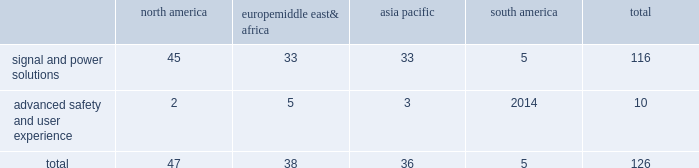Adequacy of our provision for income taxes , we regularly assess the likelihood of adverse outcomes resulting from tax examinations .
While it is often difficult to predict the final outcome or the timing of the resolution of a tax examination , our reserves for uncertain tax benefits reflect the outcome of tax positions that are more likely than not to occur .
While we believe that we have complied with all applicable tax laws , there can be no assurance that a taxing authority will not have a different interpretation of the law and assess us with additional taxes .
Should additional taxes be assessed , this may result in a material adverse effect on our results of operations and financial condition .
Item 1b .
Unresolved staff comments we have no unresolved sec staff comments to report .
Item 2 .
Properties as of december 31 , 2018 , we owned or leased 126 major manufacturing sites and 15 major technical centers .
A manufacturing site may include multiple plants and may be wholly or partially owned or leased .
We also have many smaller manufacturing sites , sales offices , warehouses , engineering centers , joint ventures and other investments strategically located throughout the world .
We have a presence in 44 countries .
The table shows the regional distribution of our major manufacturing sites by the operating segment that uses such facilities : north america europe , middle east & africa asia pacific south america total .
In addition to these manufacturing sites , we had 15 major technical centers : eight in north america ; two in europe , middle east and africa ; and five in asia pacific .
Of our 126 major manufacturing sites and 15 major technical centers , which include facilities owned or leased by our consolidated subsidiaries , 61 are primarily owned and 80 are primarily leased .
We frequently review our real estate portfolio and develop footprint strategies to support our customers 2019 global plans , while at the same time supporting our technical needs and controlling operating expenses .
We believe our evolving portfolio will meet current and anticipated future needs .
Item 3 .
Legal proceedings we are from time to time subject to various actions , claims , suits , government investigations , and other proceedings incidental to our business , including those arising out of alleged defects , breach of contracts , competition and antitrust matters , product warranties , intellectual property matters , personal injury claims and employment-related matters .
It is our opinion that the outcome of such matters will not have a material adverse impact on our consolidated financial position , results of operations , or cash flows .
With respect to warranty matters , although we cannot ensure that the future costs of warranty claims by customers will not be material , we believe our established reserves are adequate to cover potential warranty settlements .
However , the final amounts required to resolve these matters could differ materially from our recorded estimates .
Brazil matters aptiv conducts business operations in brazil that are subject to the brazilian federal labor , social security , environmental , tax and customs laws , as well as a variety of state and local laws .
While aptiv believes it complies with such laws , they are complex , subject to varying interpretations , and the company is often engaged in litigation with government agencies regarding the application of these laws to particular circumstances .
As of december 31 , 2018 , the majority of claims asserted against aptiv in brazil relate to such litigation .
The remaining claims in brazil relate to commercial and labor litigation with private parties .
As of december 31 , 2018 , claims totaling approximately $ 145 million ( using december 31 , 2018 foreign currency rates ) have been asserted against aptiv in brazil .
As of december 31 , 2018 , the company maintains accruals for these asserted claims of $ 30 million ( using december 31 , 2018 foreign currency rates ) .
The amounts accrued represent claims that are deemed probable of loss and are reasonably estimable based on the company 2019s analyses and assessment of the asserted claims and prior experience with similar matters .
While the company believes its accruals are adequate , the final amounts required to resolve these matters could differ materially from the company 2019s recorded estimates and aptiv 2019s results of .
Considering the asia pacific , what is the percentage of the signal and power solutions segment among all segments? 
Rationale: it is the number of sites related to signal and power solutions divided by the total number of sites , then turned into a percentage .
Computations: (33 / 36)
Answer: 0.91667. 